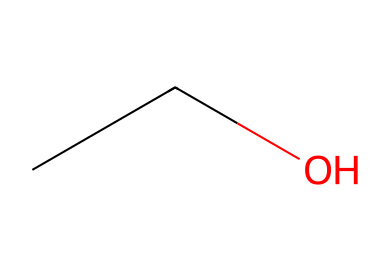What is the molecular formula of this chemical? To find the molecular formula, count the number of carbon (C), hydrogen (H), and oxygen (O) atoms in the SMILES representation. There are two carbon atoms, six hydrogen atoms, and one oxygen atom. Therefore, the molecular formula is C2H6O.
Answer: C2H6O How many carbon atoms are present in ethanol? From the SMILES representation, we can see the carbon chain which consists of two carbon atoms (C). Thus, the count of carbon atoms is 2.
Answer: 2 What is the state of ethanol at room temperature? Ethanol is known to be a liquid at room temperature (approximately 20°C). Its physical properties indicate a boiling point below room temperature, confirming its liquid state.
Answer: liquid Does ethanol have hydrogen bonding capability? The presence of an -OH (hydroxyl) group in ethanol indicates that it can form hydrogen bonds due to the electronegative oxygen atom attracting hydrogen atoms. Therefore, ethanol does exhibit hydrogen bonding.
Answer: yes What is the primary use of ethanol in hand sanitizers? Ethanol serves as a key ingredient in hand sanitizers due to its effectiveness in killing bacteria and viruses, typically at concentrations of 60% or more.
Answer: antiseptic What is the flammability classification of ethanol? Ethanol is classified as a flammable liquid due to its low flash point, which means it can ignite easily at room temperature. The classification categorizes it under flammable liquids (Class 1).
Answer: flammable What boiling point range does ethanol fall into? Ethanol boils at approximately 78-79 degrees Celsius under standard atmospheric pressure, indicating its volatility in common settings.
Answer: 78-79 degrees Celsius 